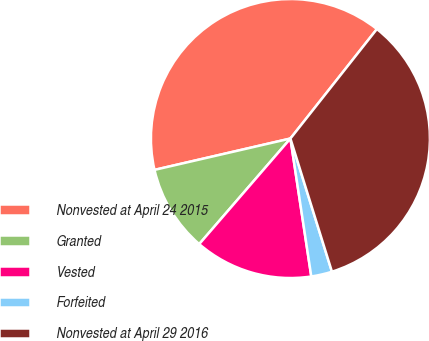Convert chart. <chart><loc_0><loc_0><loc_500><loc_500><pie_chart><fcel>Nonvested at April 24 2015<fcel>Granted<fcel>Vested<fcel>Forfeited<fcel>Nonvested at April 29 2016<nl><fcel>39.25%<fcel>10.05%<fcel>13.73%<fcel>2.42%<fcel>34.55%<nl></chart> 